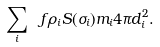<formula> <loc_0><loc_0><loc_500><loc_500>\sum _ { i } \ f { \rho _ { i } S ( \sigma _ { i } ) m _ { i } } { 4 \pi d _ { i } ^ { 2 } } .</formula> 